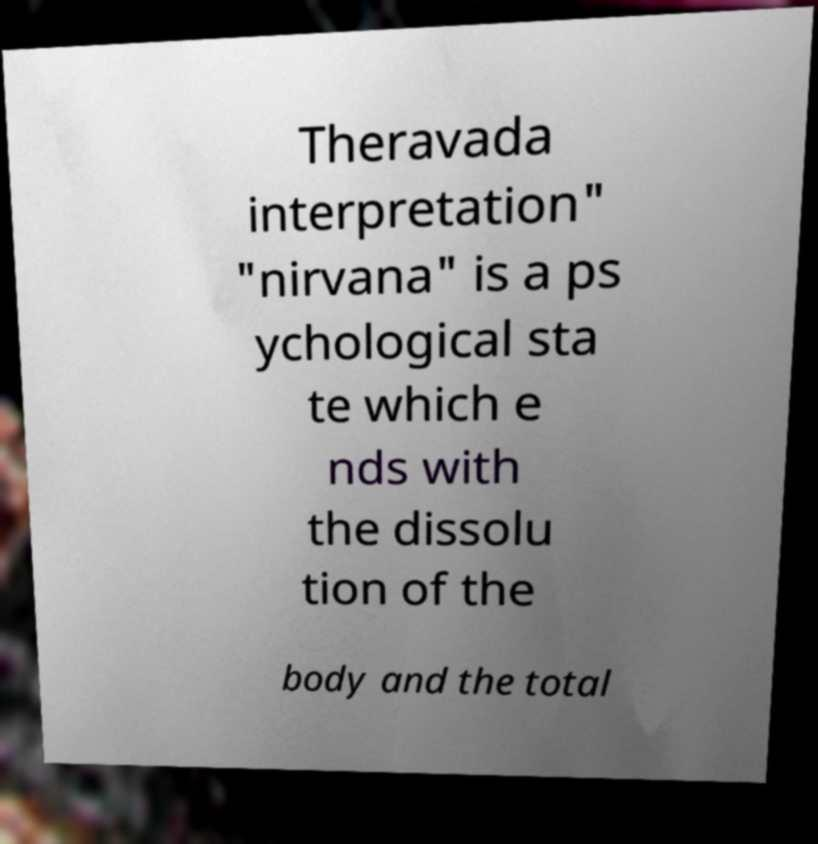Could you extract and type out the text from this image? Theravada interpretation" "nirvana" is a ps ychological sta te which e nds with the dissolu tion of the body and the total 